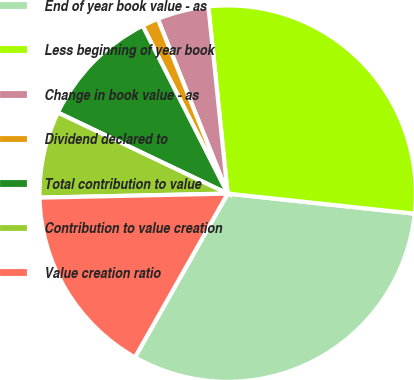<chart> <loc_0><loc_0><loc_500><loc_500><pie_chart><fcel>End of year book value - as<fcel>Less beginning of year book<fcel>Change in book value - as<fcel>Dividend declared to<fcel>Total contribution to value<fcel>Contribution to value creation<fcel>Value creation ratio<nl><fcel>31.5%<fcel>28.34%<fcel>4.42%<fcel>1.41%<fcel>10.45%<fcel>7.43%<fcel>16.46%<nl></chart> 